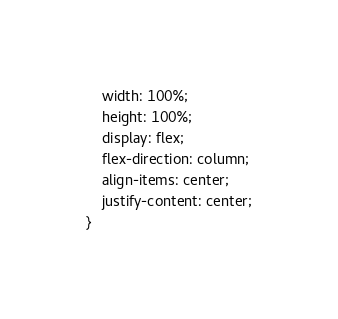Convert code to text. <code><loc_0><loc_0><loc_500><loc_500><_CSS_>    width: 100%;
    height: 100%;
    display: flex;
    flex-direction: column;
    align-items: center;
    justify-content: center;
}</code> 